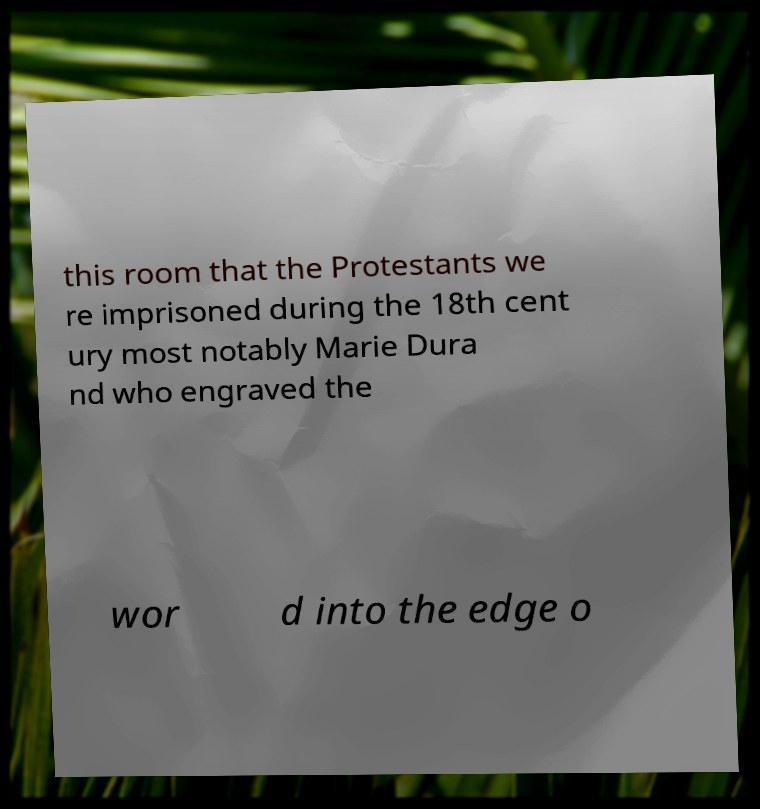Can you read and provide the text displayed in the image?This photo seems to have some interesting text. Can you extract and type it out for me? this room that the Protestants we re imprisoned during the 18th cent ury most notably Marie Dura nd who engraved the wor d into the edge o 